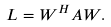<formula> <loc_0><loc_0><loc_500><loc_500>L = W ^ { H } A W .</formula> 